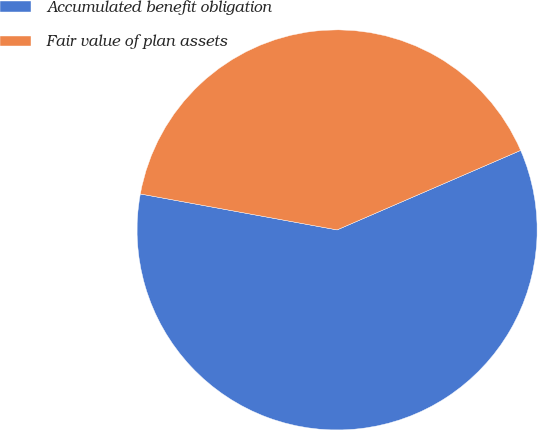Convert chart. <chart><loc_0><loc_0><loc_500><loc_500><pie_chart><fcel>Accumulated benefit obligation<fcel>Fair value of plan assets<nl><fcel>59.38%<fcel>40.62%<nl></chart> 